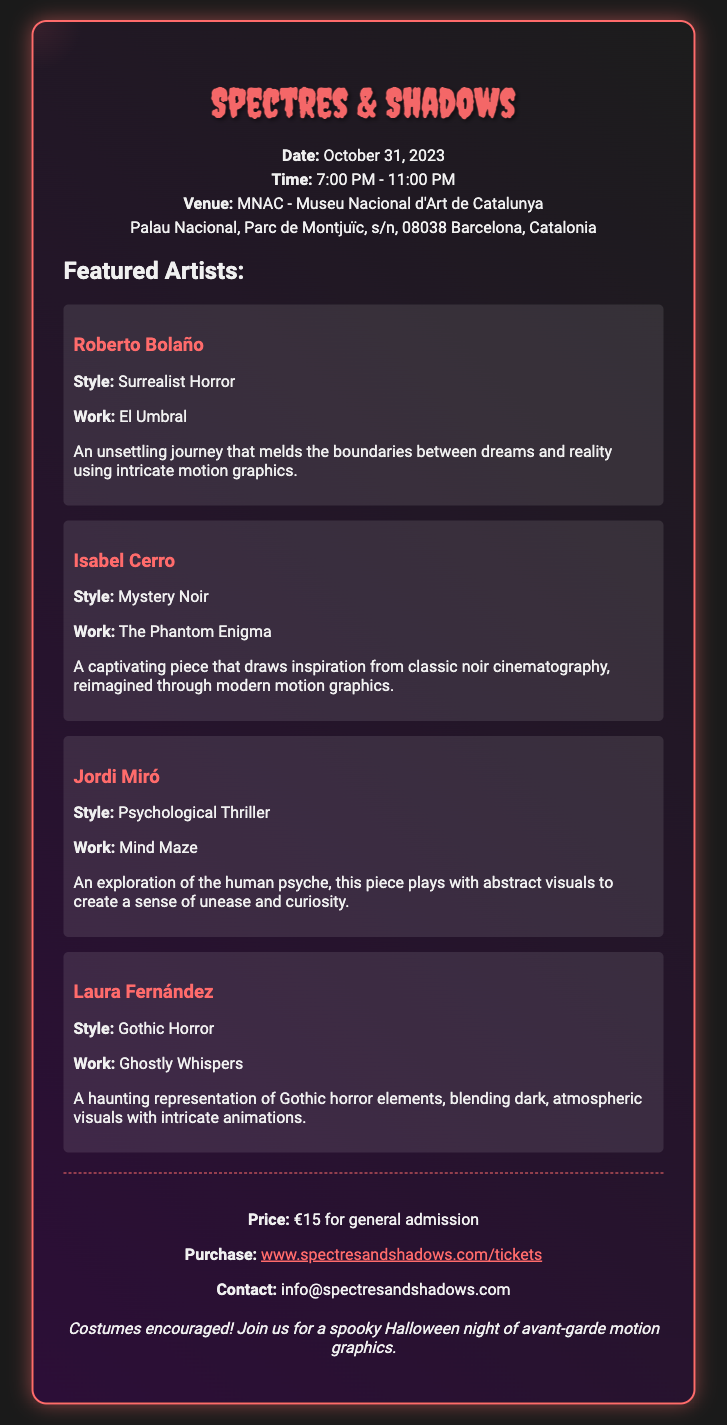What is the name of the exhibition? The title of the exhibition is the main heading in the document, prominently displayed.
Answer: Spectres & Shadows What is the date of the event? The event date is clearly stated in the event information section of the ticket.
Answer: October 31, 2023 What is the time range of the event? The time of the event is indicated in the event information section, specifying the start and end times.
Answer: 7:00 PM - 11:00 PM Where is the event taking place? The venue for the event is mentioned just below the time details.
Answer: MNAC - Museu Nacional d'Art de Catalunya Who is the artist with a work titled "Ghostly Whispers"? The artist is mentioned alongside their specific work in the artists section.
Answer: Laura Fernández Which artist's style is described as "Surrealist Horror"? This information can be gathered from the description of featured artists and their styles.
Answer: Roberto Bolaño What is the price of general admission? The price for entry is indicated in the ticket information section.
Answer: €15 What type of visuals does Jordi Miró's work create? This requires understanding the description provided under Jordi Miró's section of the artists.
Answer: A sense of unease and curiosity Is there a website link provided for ticket purchases? The ticket purchase website is specified at the end of the ticket information section.
Answer: www.spectresandshadows.com/tickets 